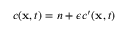<formula> <loc_0><loc_0><loc_500><loc_500>c ( x , t ) = n + \epsilon c ^ { \prime } ( x , t )</formula> 